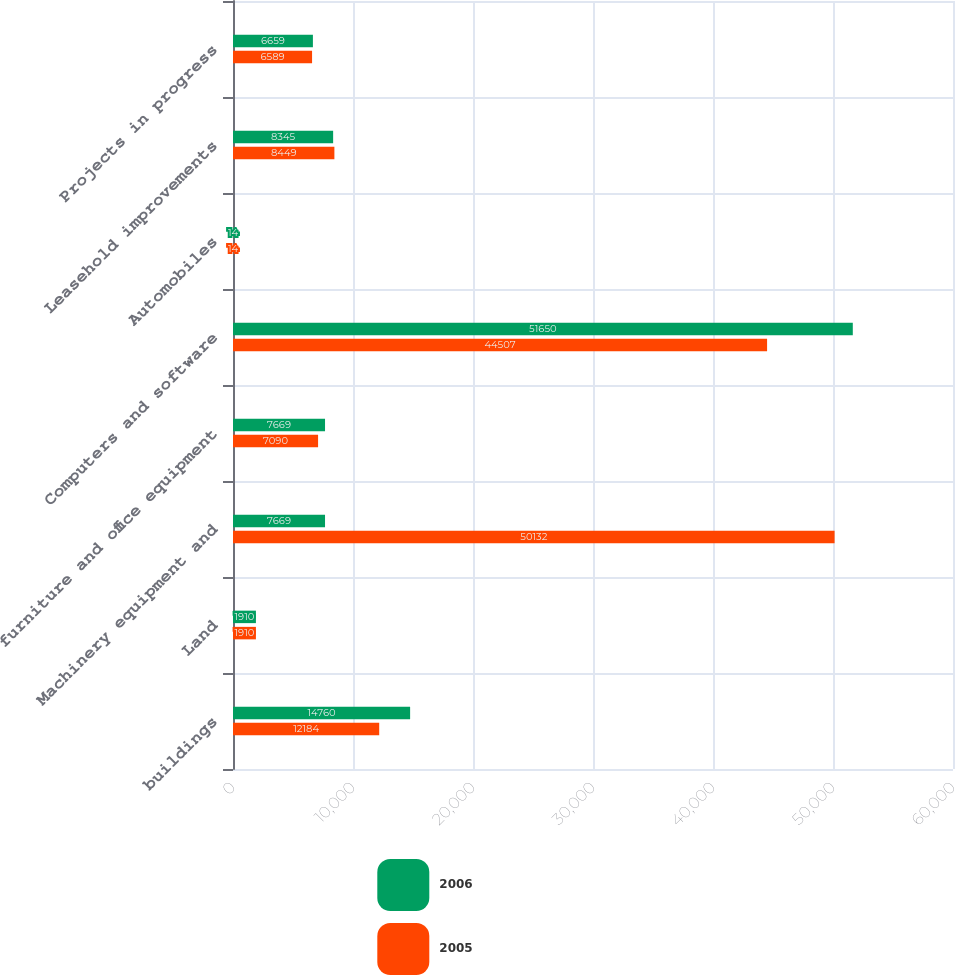Convert chart. <chart><loc_0><loc_0><loc_500><loc_500><stacked_bar_chart><ecel><fcel>buildings<fcel>Land<fcel>Machinery equipment and<fcel>furniture and office equipment<fcel>Computers and software<fcel>Automobiles<fcel>Leasehold improvements<fcel>Projects in progress<nl><fcel>2006<fcel>14760<fcel>1910<fcel>7669<fcel>7669<fcel>51650<fcel>14<fcel>8345<fcel>6659<nl><fcel>2005<fcel>12184<fcel>1910<fcel>50132<fcel>7090<fcel>44507<fcel>14<fcel>8449<fcel>6589<nl></chart> 